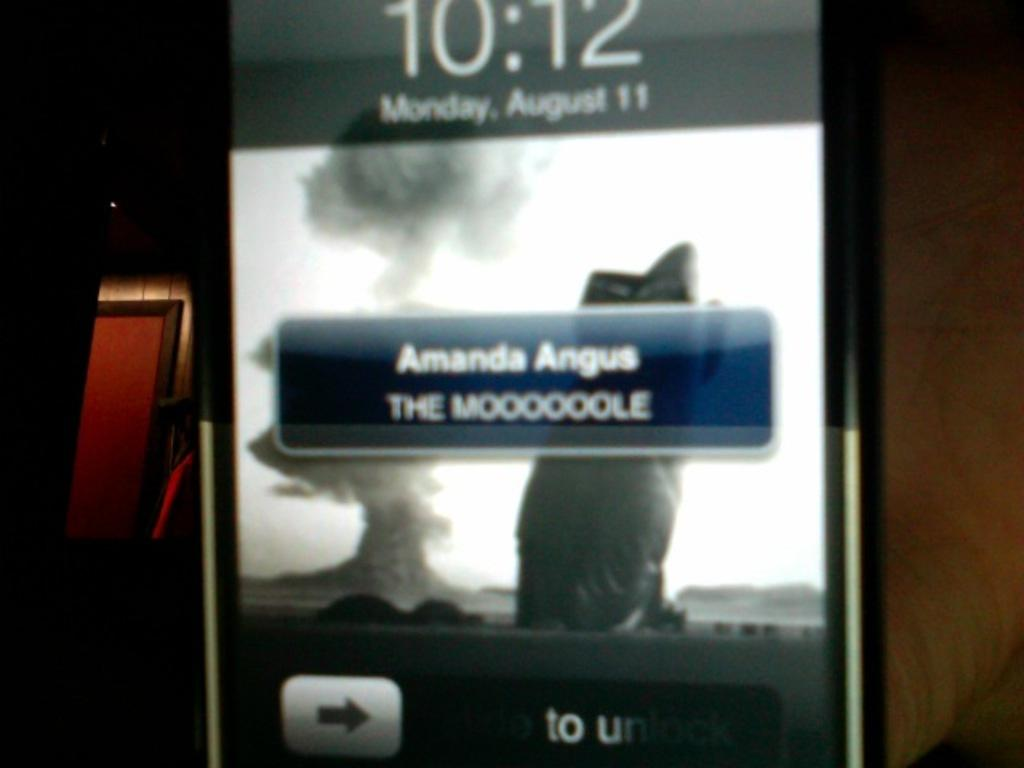<image>
Render a clear and concise summary of the photo. a phone with the name of Amanda on it 